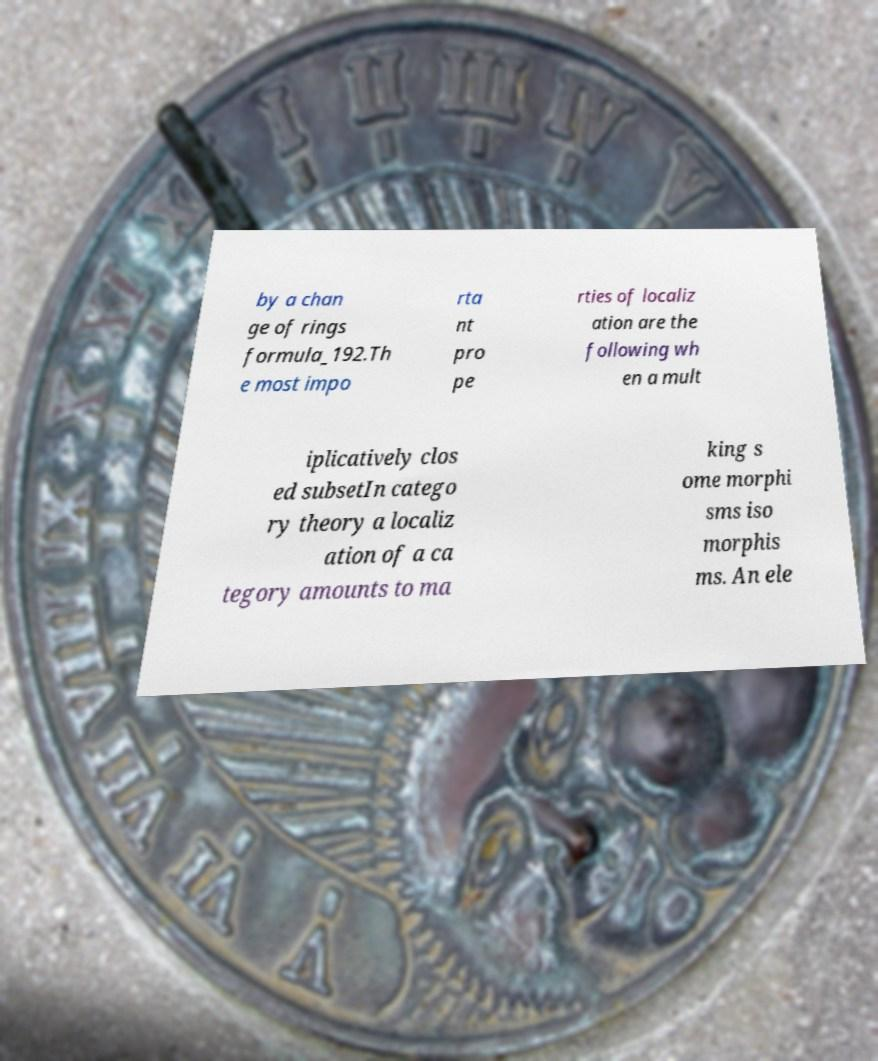Could you assist in decoding the text presented in this image and type it out clearly? by a chan ge of rings formula_192.Th e most impo rta nt pro pe rties of localiz ation are the following wh en a mult iplicatively clos ed subsetIn catego ry theory a localiz ation of a ca tegory amounts to ma king s ome morphi sms iso morphis ms. An ele 